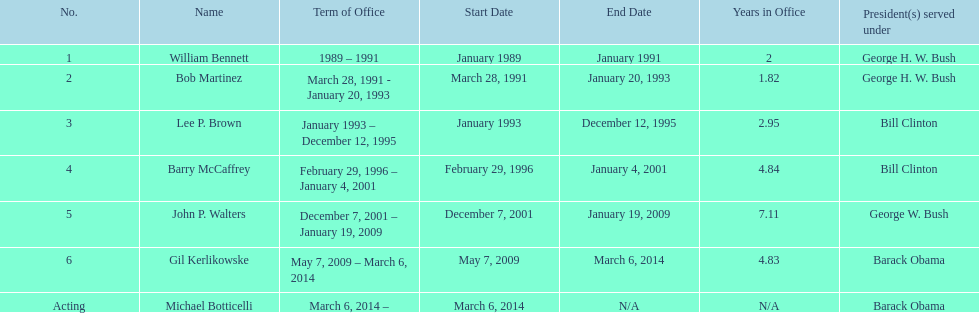Who was the next appointed director after lee p. brown? Barry McCaffrey. 